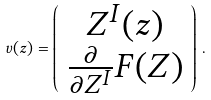Convert formula to latex. <formula><loc_0><loc_0><loc_500><loc_500>v ( z ) = \left ( \begin{array} { c } Z ^ { I } ( z ) \\ \frac { \partial } { \partial Z ^ { I } } F ( Z ) \end{array} \right ) \, .</formula> 